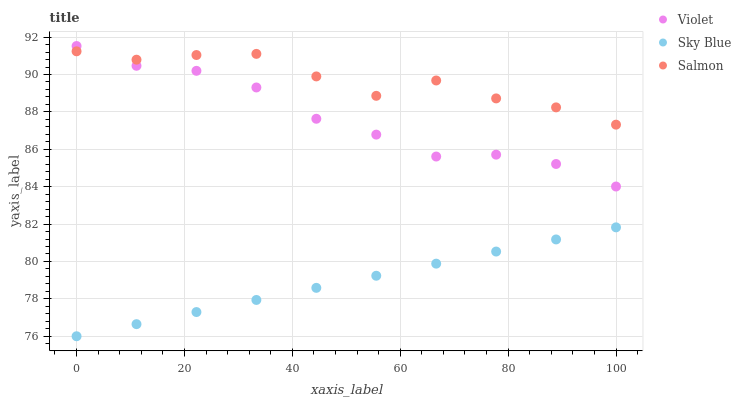Does Sky Blue have the minimum area under the curve?
Answer yes or no. Yes. Does Salmon have the maximum area under the curve?
Answer yes or no. Yes. Does Violet have the minimum area under the curve?
Answer yes or no. No. Does Violet have the maximum area under the curve?
Answer yes or no. No. Is Sky Blue the smoothest?
Answer yes or no. Yes. Is Salmon the roughest?
Answer yes or no. Yes. Is Violet the smoothest?
Answer yes or no. No. Is Violet the roughest?
Answer yes or no. No. Does Sky Blue have the lowest value?
Answer yes or no. Yes. Does Violet have the lowest value?
Answer yes or no. No. Does Violet have the highest value?
Answer yes or no. Yes. Does Salmon have the highest value?
Answer yes or no. No. Is Sky Blue less than Salmon?
Answer yes or no. Yes. Is Violet greater than Sky Blue?
Answer yes or no. Yes. Does Violet intersect Salmon?
Answer yes or no. Yes. Is Violet less than Salmon?
Answer yes or no. No. Is Violet greater than Salmon?
Answer yes or no. No. Does Sky Blue intersect Salmon?
Answer yes or no. No. 